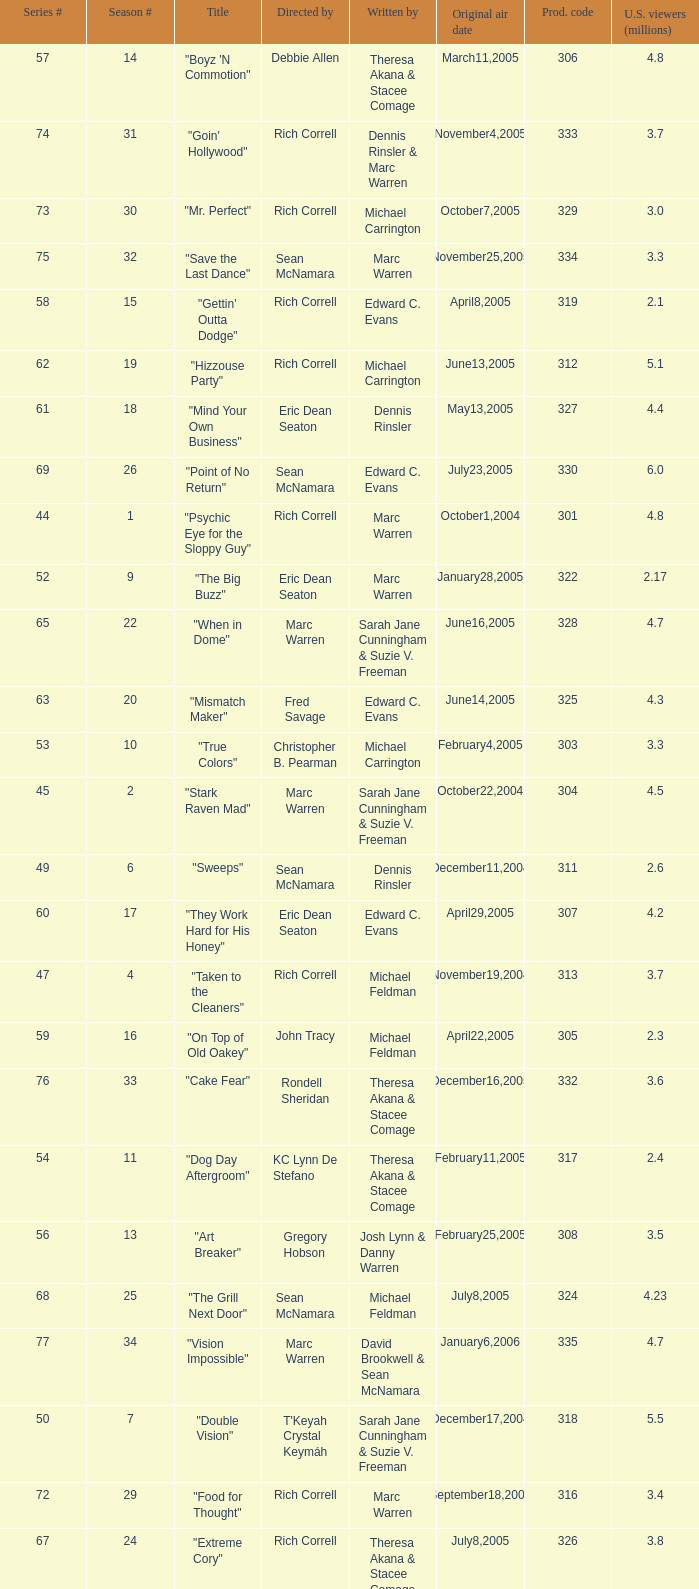Could you help me parse every detail presented in this table? {'header': ['Series #', 'Season #', 'Title', 'Directed by', 'Written by', 'Original air date', 'Prod. code', 'U.S. viewers (millions)'], 'rows': [['57', '14', '"Boyz \'N Commotion"', 'Debbie Allen', 'Theresa Akana & Stacee Comage', 'March11,2005', '306', '4.8'], ['74', '31', '"Goin\' Hollywood"', 'Rich Correll', 'Dennis Rinsler & Marc Warren', 'November4,2005', '333', '3.7'], ['73', '30', '"Mr. Perfect"', 'Rich Correll', 'Michael Carrington', 'October7,2005', '329', '3.0'], ['75', '32', '"Save the Last Dance"', 'Sean McNamara', 'Marc Warren', 'November25,2005', '334', '3.3'], ['58', '15', '"Gettin\' Outta Dodge"', 'Rich Correll', 'Edward C. Evans', 'April8,2005', '319', '2.1'], ['62', '19', '"Hizzouse Party"', 'Rich Correll', 'Michael Carrington', 'June13,2005', '312', '5.1'], ['61', '18', '"Mind Your Own Business"', 'Eric Dean Seaton', 'Dennis Rinsler', 'May13,2005', '327', '4.4'], ['69', '26', '"Point of No Return"', 'Sean McNamara', 'Edward C. Evans', 'July23,2005', '330', '6.0'], ['44', '1', '"Psychic Eye for the Sloppy Guy"', 'Rich Correll', 'Marc Warren', 'October1,2004', '301', '4.8'], ['52', '9', '"The Big Buzz"', 'Eric Dean Seaton', 'Marc Warren', 'January28,2005', '322', '2.17'], ['65', '22', '"When in Dome"', 'Marc Warren', 'Sarah Jane Cunningham & Suzie V. Freeman', 'June16,2005', '328', '4.7'], ['63', '20', '"Mismatch Maker"', 'Fred Savage', 'Edward C. Evans', 'June14,2005', '325', '4.3'], ['53', '10', '"True Colors"', 'Christopher B. Pearman', 'Michael Carrington', 'February4,2005', '303', '3.3'], ['45', '2', '"Stark Raven Mad"', 'Marc Warren', 'Sarah Jane Cunningham & Suzie V. Freeman', 'October22,2004', '304', '4.5'], ['49', '6', '"Sweeps"', 'Sean McNamara', 'Dennis Rinsler', 'December11,2004', '311', '2.6'], ['60', '17', '"They Work Hard for His Honey"', 'Eric Dean Seaton', 'Edward C. Evans', 'April29,2005', '307', '4.2'], ['47', '4', '"Taken to the Cleaners"', 'Rich Correll', 'Michael Feldman', 'November19,2004', '313', '3.7'], ['59', '16', '"On Top of Old Oakey"', 'John Tracy', 'Michael Feldman', 'April22,2005', '305', '2.3'], ['76', '33', '"Cake Fear"', 'Rondell Sheridan', 'Theresa Akana & Stacee Comage', 'December16,2005', '332', '3.6'], ['54', '11', '"Dog Day Aftergroom"', 'KC Lynn De Stefano', 'Theresa Akana & Stacee Comage', 'February11,2005', '317', '2.4'], ['56', '13', '"Art Breaker"', 'Gregory Hobson', 'Josh Lynn & Danny Warren', 'February25,2005', '308', '3.5'], ['68', '25', '"The Grill Next Door"', 'Sean McNamara', 'Michael Feldman', 'July8,2005', '324', '4.23'], ['77', '34', '"Vision Impossible"', 'Marc Warren', 'David Brookwell & Sean McNamara', 'January6,2006', '335', '4.7'], ['50', '7', '"Double Vision"', "T'Keyah Crystal Keymáh", 'Sarah Jane Cunningham & Suzie V. Freeman', 'December17,2004', '318', '5.5'], ['72', '29', '"Food for Thought"', 'Rich Correll', 'Marc Warren', 'September18,2005', '316', '3.4'], ['67', '24', '"Extreme Cory"', 'Rich Correll', 'Theresa Akana & Stacee Comage', 'July8,2005', '326', '3.8'], ['55', '12', '"Royal Treatment"', 'Christopher B. Pearman', 'Sarah Jane Cunningham & Suzie V. Freeman', 'February18,2005', '310', '2.7'], ['48', '5', '"Five Finger Discount"', 'Rich Correll', 'Dennis Rinsler', 'December3,2004', '302', '3.1'], ['66', '23', '"Too Much Pressure"', 'Rich Correll', 'Dava Savel', 'June17,2005', '323', '4.4'], ['51', '8', '"Bend It Like Baxter"', 'Rich Correll', 'Dava Savel', 'January7,2005', '315', '4.0'], ['46', '3', '"Opportunity Shocks"', 'Rich Correll', 'Dava Savel', 'November5,2004', '309', '4.5']]} What is the title of the episode directed by Rich Correll and written by Dennis Rinsler? "Five Finger Discount". 